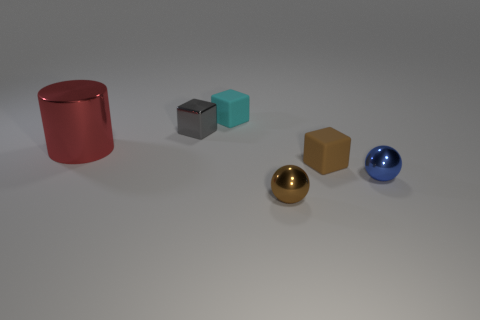Add 3 big brown metal spheres. How many objects exist? 9 Subtract all balls. How many objects are left? 4 Subtract 0 purple balls. How many objects are left? 6 Subtract all tiny green rubber objects. Subtract all tiny brown rubber cubes. How many objects are left? 5 Add 5 blue things. How many blue things are left? 6 Add 2 blue balls. How many blue balls exist? 3 